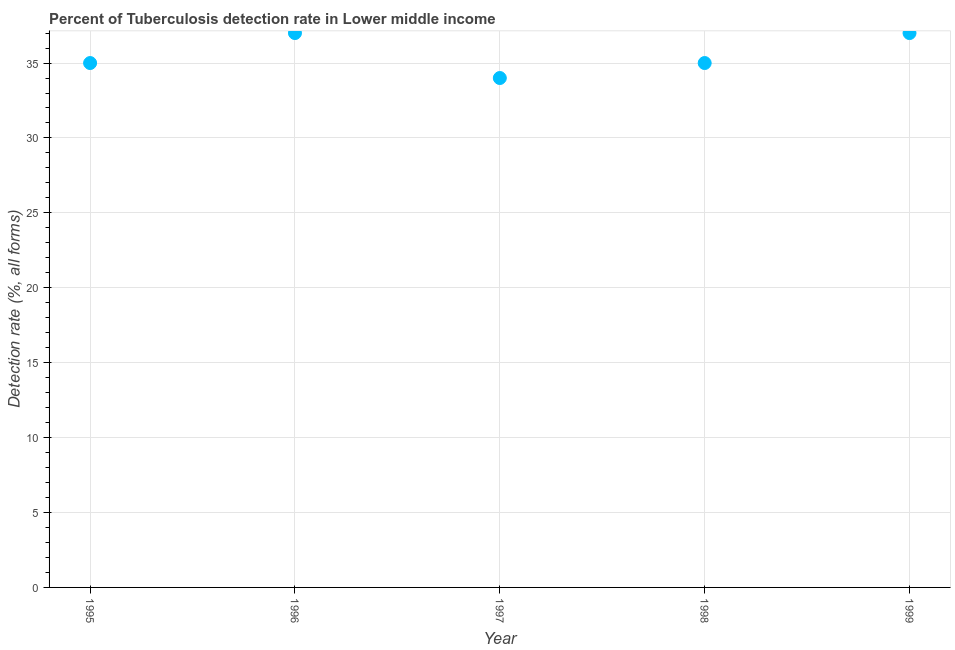What is the detection rate of tuberculosis in 1996?
Your answer should be compact. 37. Across all years, what is the maximum detection rate of tuberculosis?
Offer a very short reply. 37. Across all years, what is the minimum detection rate of tuberculosis?
Provide a succinct answer. 34. In which year was the detection rate of tuberculosis maximum?
Offer a terse response. 1996. What is the sum of the detection rate of tuberculosis?
Offer a very short reply. 178. What is the difference between the detection rate of tuberculosis in 1995 and 1997?
Provide a short and direct response. 1. What is the average detection rate of tuberculosis per year?
Ensure brevity in your answer.  35.6. What is the median detection rate of tuberculosis?
Offer a terse response. 35. In how many years, is the detection rate of tuberculosis greater than 15 %?
Your answer should be compact. 5. Do a majority of the years between 1998 and 1995 (inclusive) have detection rate of tuberculosis greater than 6 %?
Provide a succinct answer. Yes. What is the ratio of the detection rate of tuberculosis in 1997 to that in 1998?
Provide a short and direct response. 0.97. What is the difference between the highest and the lowest detection rate of tuberculosis?
Your answer should be very brief. 3. How many dotlines are there?
Your answer should be compact. 1. What is the difference between two consecutive major ticks on the Y-axis?
Your answer should be compact. 5. Does the graph contain any zero values?
Ensure brevity in your answer.  No. What is the title of the graph?
Ensure brevity in your answer.  Percent of Tuberculosis detection rate in Lower middle income. What is the label or title of the Y-axis?
Your answer should be compact. Detection rate (%, all forms). What is the Detection rate (%, all forms) in 1995?
Offer a terse response. 35. What is the Detection rate (%, all forms) in 1998?
Make the answer very short. 35. What is the difference between the Detection rate (%, all forms) in 1995 and 1997?
Give a very brief answer. 1. What is the difference between the Detection rate (%, all forms) in 1995 and 1998?
Offer a terse response. 0. What is the difference between the Detection rate (%, all forms) in 1996 and 1998?
Keep it short and to the point. 2. What is the difference between the Detection rate (%, all forms) in 1996 and 1999?
Keep it short and to the point. 0. What is the difference between the Detection rate (%, all forms) in 1997 and 1999?
Give a very brief answer. -3. What is the difference between the Detection rate (%, all forms) in 1998 and 1999?
Give a very brief answer. -2. What is the ratio of the Detection rate (%, all forms) in 1995 to that in 1996?
Offer a terse response. 0.95. What is the ratio of the Detection rate (%, all forms) in 1995 to that in 1997?
Keep it short and to the point. 1.03. What is the ratio of the Detection rate (%, all forms) in 1995 to that in 1998?
Your answer should be compact. 1. What is the ratio of the Detection rate (%, all forms) in 1995 to that in 1999?
Keep it short and to the point. 0.95. What is the ratio of the Detection rate (%, all forms) in 1996 to that in 1997?
Keep it short and to the point. 1.09. What is the ratio of the Detection rate (%, all forms) in 1996 to that in 1998?
Provide a succinct answer. 1.06. What is the ratio of the Detection rate (%, all forms) in 1997 to that in 1998?
Your response must be concise. 0.97. What is the ratio of the Detection rate (%, all forms) in 1997 to that in 1999?
Offer a very short reply. 0.92. What is the ratio of the Detection rate (%, all forms) in 1998 to that in 1999?
Provide a succinct answer. 0.95. 